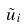Convert formula to latex. <formula><loc_0><loc_0><loc_500><loc_500>\tilde { u } _ { i }</formula> 